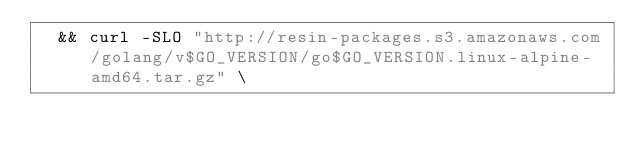Convert code to text. <code><loc_0><loc_0><loc_500><loc_500><_Dockerfile_>	&& curl -SLO "http://resin-packages.s3.amazonaws.com/golang/v$GO_VERSION/go$GO_VERSION.linux-alpine-amd64.tar.gz" \</code> 